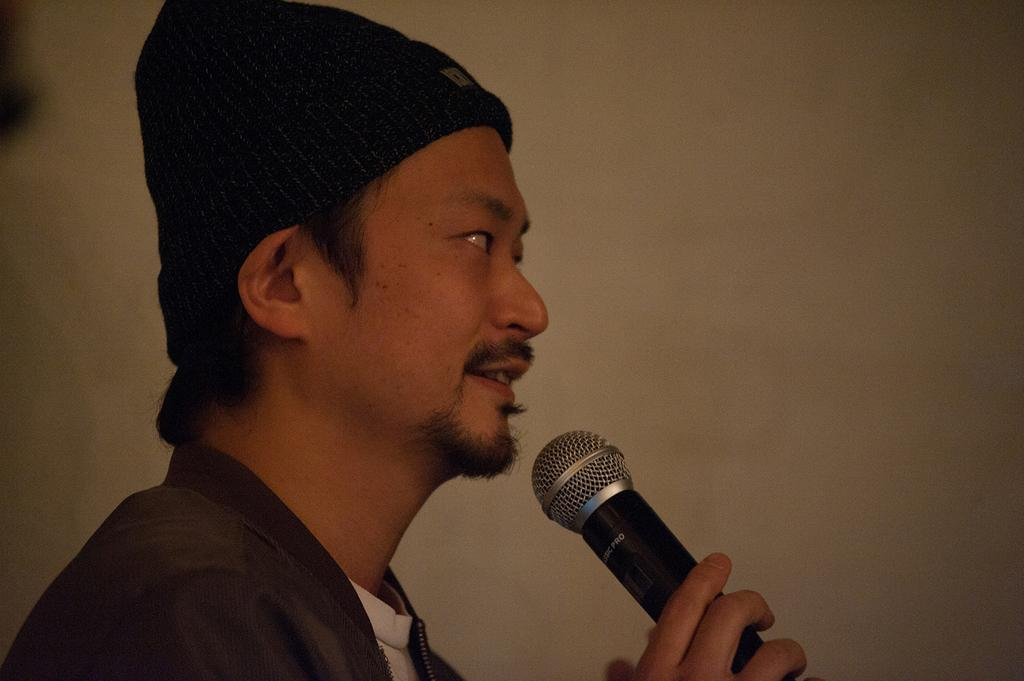What is the main subject of the image? There is a person in the image. What is the person holding in his hand? The person is holding a microphone in his hand. What is the person's focus in the image? The person is staring at someone else. What type of apple can be seen on the person's head in the image? There is no apple present on the person's head in the image. What is the weather like in the image? The provided facts do not mention the weather, so we cannot determine the weather from the image. 